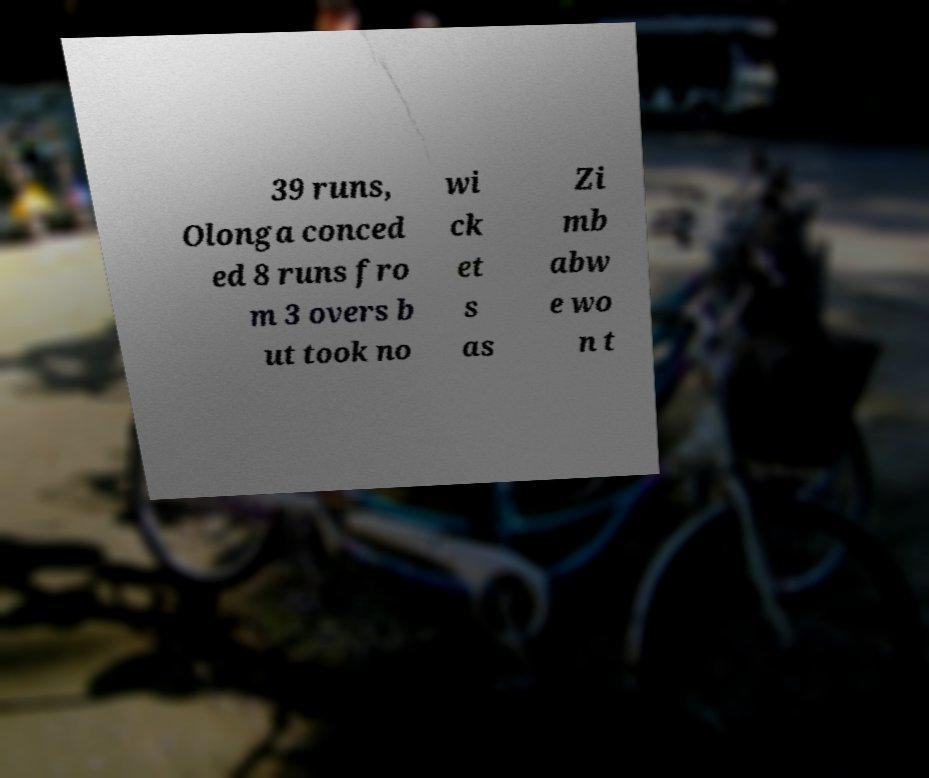Please read and relay the text visible in this image. What does it say? 39 runs, Olonga conced ed 8 runs fro m 3 overs b ut took no wi ck et s as Zi mb abw e wo n t 